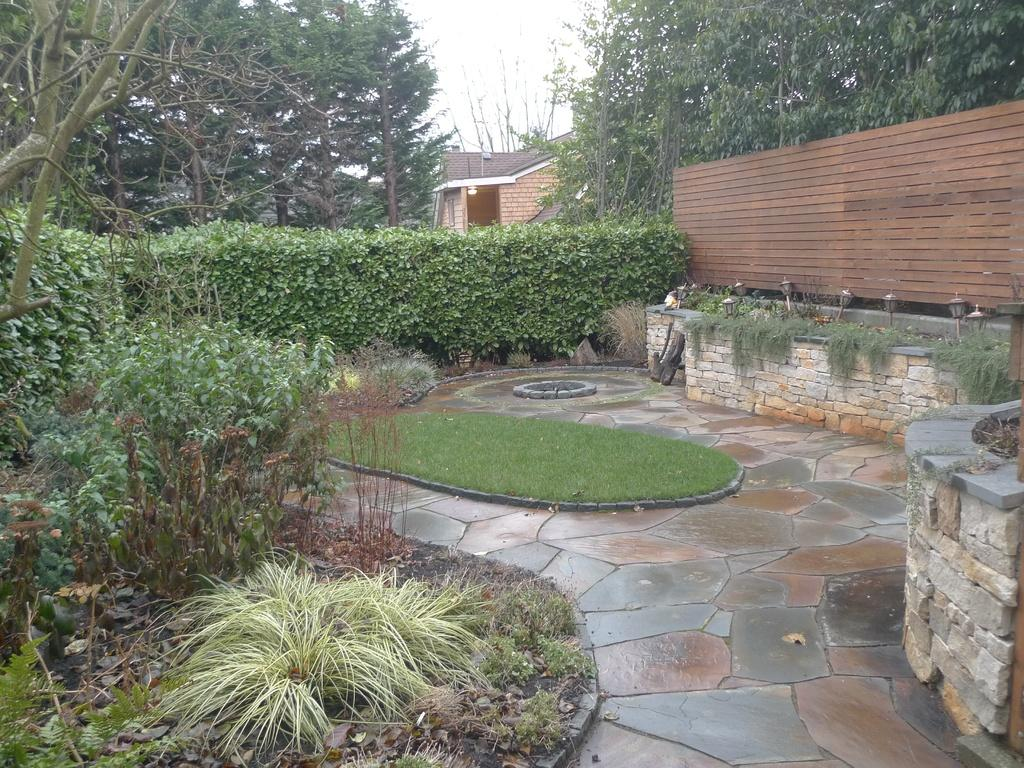What type of vegetation can be seen in the image? There are plants and a group of trees in the image. What type of ground cover is present in the image? There is grass in the image. What type of structure can be seen in the image? There is a wall in the image. What type of lighting is present in the image? There are lamps in the image. What part of the natural environment is visible in the image? The sky is visible in the image. What color is the secretary's hair in the image? There is no secretary present in the image. How many times does the paint brush move in the image? There is no paint brush present in the image. 